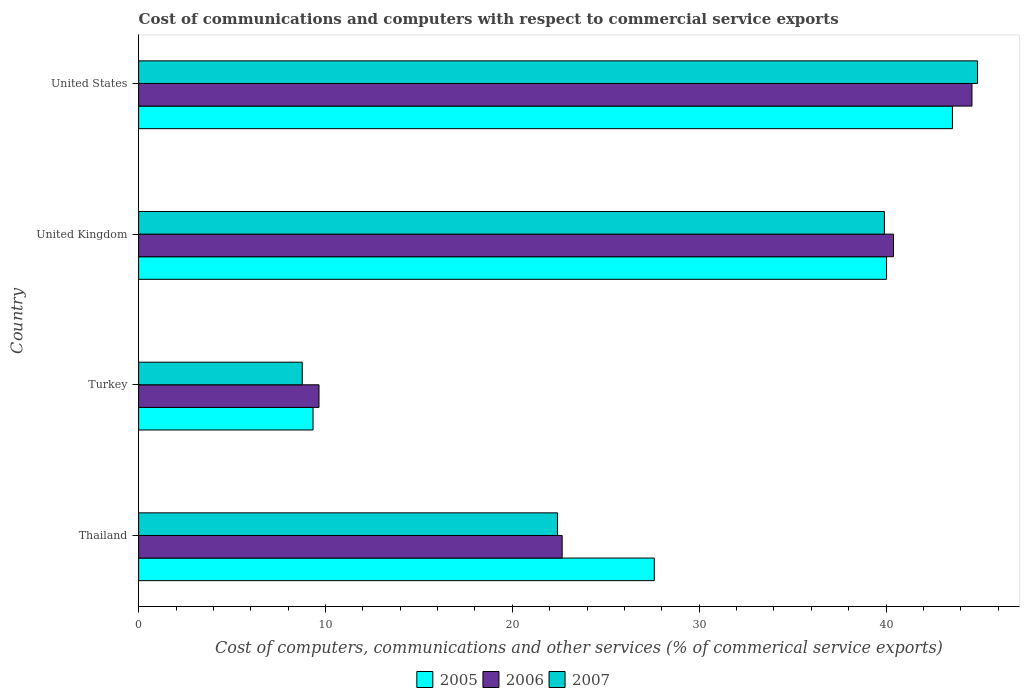How many different coloured bars are there?
Offer a very short reply. 3. How many bars are there on the 3rd tick from the top?
Offer a terse response. 3. How many bars are there on the 4th tick from the bottom?
Offer a terse response. 3. What is the label of the 4th group of bars from the top?
Offer a very short reply. Thailand. What is the cost of communications and computers in 2006 in Turkey?
Your response must be concise. 9.65. Across all countries, what is the maximum cost of communications and computers in 2006?
Provide a short and direct response. 44.6. Across all countries, what is the minimum cost of communications and computers in 2007?
Make the answer very short. 8.76. In which country was the cost of communications and computers in 2007 maximum?
Keep it short and to the point. United States. What is the total cost of communications and computers in 2005 in the graph?
Make the answer very short. 120.51. What is the difference between the cost of communications and computers in 2007 in Turkey and that in United Kingdom?
Give a very brief answer. -31.15. What is the difference between the cost of communications and computers in 2007 in Thailand and the cost of communications and computers in 2006 in United States?
Provide a short and direct response. -22.18. What is the average cost of communications and computers in 2007 per country?
Your answer should be very brief. 28.99. What is the difference between the cost of communications and computers in 2006 and cost of communications and computers in 2007 in United States?
Your answer should be very brief. -0.3. What is the ratio of the cost of communications and computers in 2007 in Turkey to that in United Kingdom?
Offer a very short reply. 0.22. Is the difference between the cost of communications and computers in 2006 in Thailand and United Kingdom greater than the difference between the cost of communications and computers in 2007 in Thailand and United Kingdom?
Make the answer very short. No. What is the difference between the highest and the second highest cost of communications and computers in 2006?
Give a very brief answer. 4.2. What is the difference between the highest and the lowest cost of communications and computers in 2006?
Ensure brevity in your answer.  34.94. Is the sum of the cost of communications and computers in 2007 in Turkey and United States greater than the maximum cost of communications and computers in 2006 across all countries?
Keep it short and to the point. Yes. What does the 2nd bar from the top in United Kingdom represents?
Your response must be concise. 2006. What does the 2nd bar from the bottom in United Kingdom represents?
Your response must be concise. 2006. Is it the case that in every country, the sum of the cost of communications and computers in 2005 and cost of communications and computers in 2006 is greater than the cost of communications and computers in 2007?
Give a very brief answer. Yes. How many bars are there?
Ensure brevity in your answer.  12. Are all the bars in the graph horizontal?
Offer a very short reply. Yes. Does the graph contain any zero values?
Your answer should be compact. No. How are the legend labels stacked?
Make the answer very short. Horizontal. What is the title of the graph?
Provide a short and direct response. Cost of communications and computers with respect to commercial service exports. Does "1981" appear as one of the legend labels in the graph?
Ensure brevity in your answer.  No. What is the label or title of the X-axis?
Give a very brief answer. Cost of computers, communications and other services (% of commerical service exports). What is the Cost of computers, communications and other services (% of commerical service exports) in 2005 in Thailand?
Give a very brief answer. 27.6. What is the Cost of computers, communications and other services (% of commerical service exports) of 2006 in Thailand?
Provide a short and direct response. 22.66. What is the Cost of computers, communications and other services (% of commerical service exports) of 2007 in Thailand?
Offer a terse response. 22.42. What is the Cost of computers, communications and other services (% of commerical service exports) of 2005 in Turkey?
Provide a succinct answer. 9.33. What is the Cost of computers, communications and other services (% of commerical service exports) in 2006 in Turkey?
Make the answer very short. 9.65. What is the Cost of computers, communications and other services (% of commerical service exports) of 2007 in Turkey?
Keep it short and to the point. 8.76. What is the Cost of computers, communications and other services (% of commerical service exports) in 2005 in United Kingdom?
Provide a short and direct response. 40.03. What is the Cost of computers, communications and other services (% of commerical service exports) in 2006 in United Kingdom?
Make the answer very short. 40.39. What is the Cost of computers, communications and other services (% of commerical service exports) of 2007 in United Kingdom?
Keep it short and to the point. 39.91. What is the Cost of computers, communications and other services (% of commerical service exports) in 2005 in United States?
Ensure brevity in your answer.  43.55. What is the Cost of computers, communications and other services (% of commerical service exports) of 2006 in United States?
Offer a very short reply. 44.6. What is the Cost of computers, communications and other services (% of commerical service exports) in 2007 in United States?
Ensure brevity in your answer.  44.89. Across all countries, what is the maximum Cost of computers, communications and other services (% of commerical service exports) of 2005?
Your answer should be compact. 43.55. Across all countries, what is the maximum Cost of computers, communications and other services (% of commerical service exports) of 2006?
Provide a succinct answer. 44.6. Across all countries, what is the maximum Cost of computers, communications and other services (% of commerical service exports) of 2007?
Ensure brevity in your answer.  44.89. Across all countries, what is the minimum Cost of computers, communications and other services (% of commerical service exports) in 2005?
Provide a succinct answer. 9.33. Across all countries, what is the minimum Cost of computers, communications and other services (% of commerical service exports) of 2006?
Ensure brevity in your answer.  9.65. Across all countries, what is the minimum Cost of computers, communications and other services (% of commerical service exports) in 2007?
Your answer should be compact. 8.76. What is the total Cost of computers, communications and other services (% of commerical service exports) in 2005 in the graph?
Your answer should be very brief. 120.51. What is the total Cost of computers, communications and other services (% of commerical service exports) of 2006 in the graph?
Your response must be concise. 117.31. What is the total Cost of computers, communications and other services (% of commerical service exports) of 2007 in the graph?
Your answer should be compact. 115.98. What is the difference between the Cost of computers, communications and other services (% of commerical service exports) of 2005 in Thailand and that in Turkey?
Ensure brevity in your answer.  18.26. What is the difference between the Cost of computers, communications and other services (% of commerical service exports) in 2006 in Thailand and that in Turkey?
Ensure brevity in your answer.  13.01. What is the difference between the Cost of computers, communications and other services (% of commerical service exports) of 2007 in Thailand and that in Turkey?
Provide a succinct answer. 13.66. What is the difference between the Cost of computers, communications and other services (% of commerical service exports) of 2005 in Thailand and that in United Kingdom?
Make the answer very short. -12.43. What is the difference between the Cost of computers, communications and other services (% of commerical service exports) in 2006 in Thailand and that in United Kingdom?
Offer a terse response. -17.73. What is the difference between the Cost of computers, communications and other services (% of commerical service exports) of 2007 in Thailand and that in United Kingdom?
Your response must be concise. -17.49. What is the difference between the Cost of computers, communications and other services (% of commerical service exports) in 2005 in Thailand and that in United States?
Your response must be concise. -15.95. What is the difference between the Cost of computers, communications and other services (% of commerical service exports) in 2006 in Thailand and that in United States?
Keep it short and to the point. -21.93. What is the difference between the Cost of computers, communications and other services (% of commerical service exports) in 2007 in Thailand and that in United States?
Give a very brief answer. -22.48. What is the difference between the Cost of computers, communications and other services (% of commerical service exports) of 2005 in Turkey and that in United Kingdom?
Offer a very short reply. -30.69. What is the difference between the Cost of computers, communications and other services (% of commerical service exports) of 2006 in Turkey and that in United Kingdom?
Offer a terse response. -30.74. What is the difference between the Cost of computers, communications and other services (% of commerical service exports) of 2007 in Turkey and that in United Kingdom?
Your response must be concise. -31.15. What is the difference between the Cost of computers, communications and other services (% of commerical service exports) in 2005 in Turkey and that in United States?
Your response must be concise. -34.22. What is the difference between the Cost of computers, communications and other services (% of commerical service exports) of 2006 in Turkey and that in United States?
Keep it short and to the point. -34.94. What is the difference between the Cost of computers, communications and other services (% of commerical service exports) in 2007 in Turkey and that in United States?
Your response must be concise. -36.14. What is the difference between the Cost of computers, communications and other services (% of commerical service exports) of 2005 in United Kingdom and that in United States?
Make the answer very short. -3.53. What is the difference between the Cost of computers, communications and other services (% of commerical service exports) of 2006 in United Kingdom and that in United States?
Make the answer very short. -4.2. What is the difference between the Cost of computers, communications and other services (% of commerical service exports) of 2007 in United Kingdom and that in United States?
Offer a terse response. -4.98. What is the difference between the Cost of computers, communications and other services (% of commerical service exports) in 2005 in Thailand and the Cost of computers, communications and other services (% of commerical service exports) in 2006 in Turkey?
Keep it short and to the point. 17.94. What is the difference between the Cost of computers, communications and other services (% of commerical service exports) of 2005 in Thailand and the Cost of computers, communications and other services (% of commerical service exports) of 2007 in Turkey?
Offer a terse response. 18.84. What is the difference between the Cost of computers, communications and other services (% of commerical service exports) of 2006 in Thailand and the Cost of computers, communications and other services (% of commerical service exports) of 2007 in Turkey?
Offer a terse response. 13.91. What is the difference between the Cost of computers, communications and other services (% of commerical service exports) in 2005 in Thailand and the Cost of computers, communications and other services (% of commerical service exports) in 2006 in United Kingdom?
Keep it short and to the point. -12.8. What is the difference between the Cost of computers, communications and other services (% of commerical service exports) of 2005 in Thailand and the Cost of computers, communications and other services (% of commerical service exports) of 2007 in United Kingdom?
Offer a terse response. -12.31. What is the difference between the Cost of computers, communications and other services (% of commerical service exports) in 2006 in Thailand and the Cost of computers, communications and other services (% of commerical service exports) in 2007 in United Kingdom?
Your answer should be very brief. -17.25. What is the difference between the Cost of computers, communications and other services (% of commerical service exports) of 2005 in Thailand and the Cost of computers, communications and other services (% of commerical service exports) of 2006 in United States?
Your answer should be very brief. -17. What is the difference between the Cost of computers, communications and other services (% of commerical service exports) of 2005 in Thailand and the Cost of computers, communications and other services (% of commerical service exports) of 2007 in United States?
Give a very brief answer. -17.3. What is the difference between the Cost of computers, communications and other services (% of commerical service exports) in 2006 in Thailand and the Cost of computers, communications and other services (% of commerical service exports) in 2007 in United States?
Provide a succinct answer. -22.23. What is the difference between the Cost of computers, communications and other services (% of commerical service exports) in 2005 in Turkey and the Cost of computers, communications and other services (% of commerical service exports) in 2006 in United Kingdom?
Offer a terse response. -31.06. What is the difference between the Cost of computers, communications and other services (% of commerical service exports) in 2005 in Turkey and the Cost of computers, communications and other services (% of commerical service exports) in 2007 in United Kingdom?
Ensure brevity in your answer.  -30.58. What is the difference between the Cost of computers, communications and other services (% of commerical service exports) of 2006 in Turkey and the Cost of computers, communications and other services (% of commerical service exports) of 2007 in United Kingdom?
Provide a short and direct response. -30.26. What is the difference between the Cost of computers, communications and other services (% of commerical service exports) of 2005 in Turkey and the Cost of computers, communications and other services (% of commerical service exports) of 2006 in United States?
Keep it short and to the point. -35.26. What is the difference between the Cost of computers, communications and other services (% of commerical service exports) of 2005 in Turkey and the Cost of computers, communications and other services (% of commerical service exports) of 2007 in United States?
Ensure brevity in your answer.  -35.56. What is the difference between the Cost of computers, communications and other services (% of commerical service exports) of 2006 in Turkey and the Cost of computers, communications and other services (% of commerical service exports) of 2007 in United States?
Ensure brevity in your answer.  -35.24. What is the difference between the Cost of computers, communications and other services (% of commerical service exports) in 2005 in United Kingdom and the Cost of computers, communications and other services (% of commerical service exports) in 2006 in United States?
Your answer should be very brief. -4.57. What is the difference between the Cost of computers, communications and other services (% of commerical service exports) of 2005 in United Kingdom and the Cost of computers, communications and other services (% of commerical service exports) of 2007 in United States?
Your answer should be very brief. -4.87. What is the difference between the Cost of computers, communications and other services (% of commerical service exports) in 2006 in United Kingdom and the Cost of computers, communications and other services (% of commerical service exports) in 2007 in United States?
Keep it short and to the point. -4.5. What is the average Cost of computers, communications and other services (% of commerical service exports) in 2005 per country?
Make the answer very short. 30.13. What is the average Cost of computers, communications and other services (% of commerical service exports) in 2006 per country?
Make the answer very short. 29.33. What is the average Cost of computers, communications and other services (% of commerical service exports) of 2007 per country?
Your answer should be very brief. 28.99. What is the difference between the Cost of computers, communications and other services (% of commerical service exports) of 2005 and Cost of computers, communications and other services (% of commerical service exports) of 2006 in Thailand?
Provide a short and direct response. 4.93. What is the difference between the Cost of computers, communications and other services (% of commerical service exports) in 2005 and Cost of computers, communications and other services (% of commerical service exports) in 2007 in Thailand?
Keep it short and to the point. 5.18. What is the difference between the Cost of computers, communications and other services (% of commerical service exports) of 2006 and Cost of computers, communications and other services (% of commerical service exports) of 2007 in Thailand?
Make the answer very short. 0.25. What is the difference between the Cost of computers, communications and other services (% of commerical service exports) in 2005 and Cost of computers, communications and other services (% of commerical service exports) in 2006 in Turkey?
Offer a terse response. -0.32. What is the difference between the Cost of computers, communications and other services (% of commerical service exports) of 2005 and Cost of computers, communications and other services (% of commerical service exports) of 2007 in Turkey?
Provide a short and direct response. 0.58. What is the difference between the Cost of computers, communications and other services (% of commerical service exports) of 2006 and Cost of computers, communications and other services (% of commerical service exports) of 2007 in Turkey?
Provide a succinct answer. 0.9. What is the difference between the Cost of computers, communications and other services (% of commerical service exports) of 2005 and Cost of computers, communications and other services (% of commerical service exports) of 2006 in United Kingdom?
Offer a terse response. -0.37. What is the difference between the Cost of computers, communications and other services (% of commerical service exports) of 2005 and Cost of computers, communications and other services (% of commerical service exports) of 2007 in United Kingdom?
Your answer should be very brief. 0.12. What is the difference between the Cost of computers, communications and other services (% of commerical service exports) in 2006 and Cost of computers, communications and other services (% of commerical service exports) in 2007 in United Kingdom?
Keep it short and to the point. 0.48. What is the difference between the Cost of computers, communications and other services (% of commerical service exports) in 2005 and Cost of computers, communications and other services (% of commerical service exports) in 2006 in United States?
Ensure brevity in your answer.  -1.05. What is the difference between the Cost of computers, communications and other services (% of commerical service exports) of 2005 and Cost of computers, communications and other services (% of commerical service exports) of 2007 in United States?
Your answer should be very brief. -1.34. What is the difference between the Cost of computers, communications and other services (% of commerical service exports) in 2006 and Cost of computers, communications and other services (% of commerical service exports) in 2007 in United States?
Provide a short and direct response. -0.3. What is the ratio of the Cost of computers, communications and other services (% of commerical service exports) in 2005 in Thailand to that in Turkey?
Make the answer very short. 2.96. What is the ratio of the Cost of computers, communications and other services (% of commerical service exports) of 2006 in Thailand to that in Turkey?
Your answer should be compact. 2.35. What is the ratio of the Cost of computers, communications and other services (% of commerical service exports) of 2007 in Thailand to that in Turkey?
Make the answer very short. 2.56. What is the ratio of the Cost of computers, communications and other services (% of commerical service exports) in 2005 in Thailand to that in United Kingdom?
Provide a succinct answer. 0.69. What is the ratio of the Cost of computers, communications and other services (% of commerical service exports) in 2006 in Thailand to that in United Kingdom?
Keep it short and to the point. 0.56. What is the ratio of the Cost of computers, communications and other services (% of commerical service exports) in 2007 in Thailand to that in United Kingdom?
Offer a terse response. 0.56. What is the ratio of the Cost of computers, communications and other services (% of commerical service exports) of 2005 in Thailand to that in United States?
Give a very brief answer. 0.63. What is the ratio of the Cost of computers, communications and other services (% of commerical service exports) in 2006 in Thailand to that in United States?
Offer a very short reply. 0.51. What is the ratio of the Cost of computers, communications and other services (% of commerical service exports) of 2007 in Thailand to that in United States?
Give a very brief answer. 0.5. What is the ratio of the Cost of computers, communications and other services (% of commerical service exports) of 2005 in Turkey to that in United Kingdom?
Your answer should be compact. 0.23. What is the ratio of the Cost of computers, communications and other services (% of commerical service exports) of 2006 in Turkey to that in United Kingdom?
Give a very brief answer. 0.24. What is the ratio of the Cost of computers, communications and other services (% of commerical service exports) of 2007 in Turkey to that in United Kingdom?
Provide a succinct answer. 0.22. What is the ratio of the Cost of computers, communications and other services (% of commerical service exports) of 2005 in Turkey to that in United States?
Your response must be concise. 0.21. What is the ratio of the Cost of computers, communications and other services (% of commerical service exports) in 2006 in Turkey to that in United States?
Provide a succinct answer. 0.22. What is the ratio of the Cost of computers, communications and other services (% of commerical service exports) of 2007 in Turkey to that in United States?
Offer a terse response. 0.2. What is the ratio of the Cost of computers, communications and other services (% of commerical service exports) of 2005 in United Kingdom to that in United States?
Offer a very short reply. 0.92. What is the ratio of the Cost of computers, communications and other services (% of commerical service exports) in 2006 in United Kingdom to that in United States?
Keep it short and to the point. 0.91. What is the ratio of the Cost of computers, communications and other services (% of commerical service exports) in 2007 in United Kingdom to that in United States?
Your answer should be very brief. 0.89. What is the difference between the highest and the second highest Cost of computers, communications and other services (% of commerical service exports) in 2005?
Your response must be concise. 3.53. What is the difference between the highest and the second highest Cost of computers, communications and other services (% of commerical service exports) of 2006?
Offer a very short reply. 4.2. What is the difference between the highest and the second highest Cost of computers, communications and other services (% of commerical service exports) in 2007?
Provide a short and direct response. 4.98. What is the difference between the highest and the lowest Cost of computers, communications and other services (% of commerical service exports) of 2005?
Provide a short and direct response. 34.22. What is the difference between the highest and the lowest Cost of computers, communications and other services (% of commerical service exports) in 2006?
Offer a very short reply. 34.94. What is the difference between the highest and the lowest Cost of computers, communications and other services (% of commerical service exports) in 2007?
Make the answer very short. 36.14. 